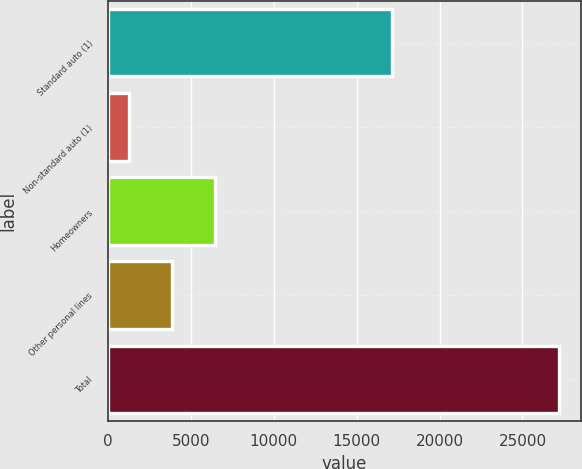Convert chart. <chart><loc_0><loc_0><loc_500><loc_500><bar_chart><fcel>Standard auto (1)<fcel>Non-standard auto (1)<fcel>Homeowners<fcel>Other personal lines<fcel>Total<nl><fcel>17160<fcel>1247<fcel>6434.2<fcel>3840.6<fcel>27183<nl></chart> 